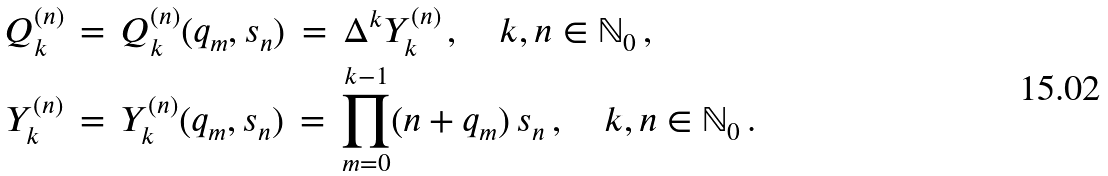<formula> <loc_0><loc_0><loc_500><loc_500>Q _ { k } ^ { ( n ) } & \, = \, Q _ { k } ^ { ( n ) } ( q _ { m } , s _ { n } ) \, = \, \Delta ^ { k } Y _ { k } ^ { ( n ) } \, , \quad k , n \in \mathbb { N } _ { 0 } \, , \\ Y _ { k } ^ { ( n ) } & \, = \, Y _ { k } ^ { ( n ) } ( q _ { m } , s _ { n } ) \, = \, \prod _ { m = 0 } ^ { k - 1 } ( n + q _ { m } ) \, s _ { n } \, , \quad k , n \in \mathbb { N } _ { 0 } \, .</formula> 